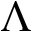Convert formula to latex. <formula><loc_0><loc_0><loc_500><loc_500>\Lambda</formula> 